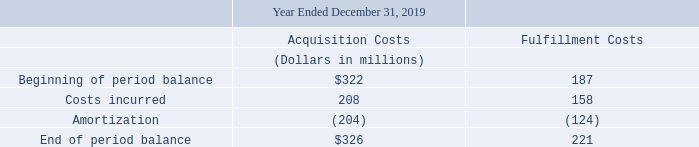Contract Costs
The following table provides changes in our contract acquisition costs and fulfillment costs:
Acquisition costs include commission fees paid to employees as a result of obtaining contracts. Fulfillment costs include third party and internal costs associated with the provision, installation and activation of telecommunications services to customers, including labor and materials consumed for these activities.
Deferred acquisition and fulfillment costs are amortized based on the transfer of services on a straight-line basis over the average customer life of 30 months for consumer customers and 12 to 60 months for business customers and amortized fulfillment costs are included in cost of services and products and amortized acquisition costs are included in selling, general and administrative expenses in our consolidated statements of operations. The amount of these deferred costs that are anticipated to be amortized in the next twelve months are included in other current assets on our consolidated balance sheets. The amount of deferred costs expected to be amortized beyond the next twelve months is included in other non-current assets on our consolidated balance sheets. Deferred acquisition and fulfillment costs are assessed for impairment on an annual basis.
What do the fulfillment costs include? Third party and internal costs associated with the provision, installation and activation of telecommunications services to customers, including labor and materials consumed for these activities. How are the deferred acquisition and fulfillment costs amortized? Based on the transfer of services on a straight-line basis over the average customer life of 30 months for consumer customers and 12 to 60 months for business customers. What are the types of costs highlighted in the table? Acquisition costs, fulfillment costs. Which type of costs has a larger amount under costs incurred? 208>158
Answer: acquisition costs. What is the sum of the end of period balance costs for 2019?
Answer scale should be: million. 326+221
Answer: 547. What is the percentage change for the end of period balance for Fulfillment Costs when comparing the beginning of period balance?
Answer scale should be: percent. (221-187)/187
Answer: 18.18. 